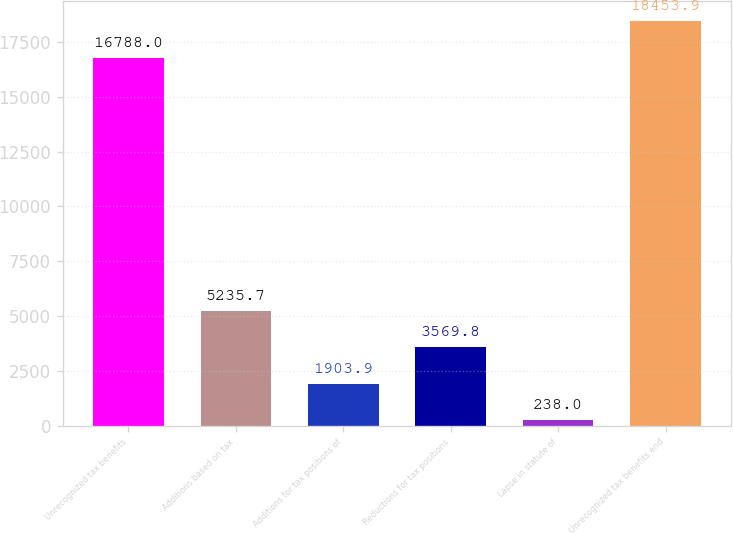Convert chart to OTSL. <chart><loc_0><loc_0><loc_500><loc_500><bar_chart><fcel>Unrecognized tax benefits<fcel>Additions based on tax<fcel>Additions for tax positions of<fcel>Reductions for tax positions<fcel>Lapse in statute of<fcel>Unrecognized tax benefits end<nl><fcel>16788<fcel>5235.7<fcel>1903.9<fcel>3569.8<fcel>238<fcel>18453.9<nl></chart> 